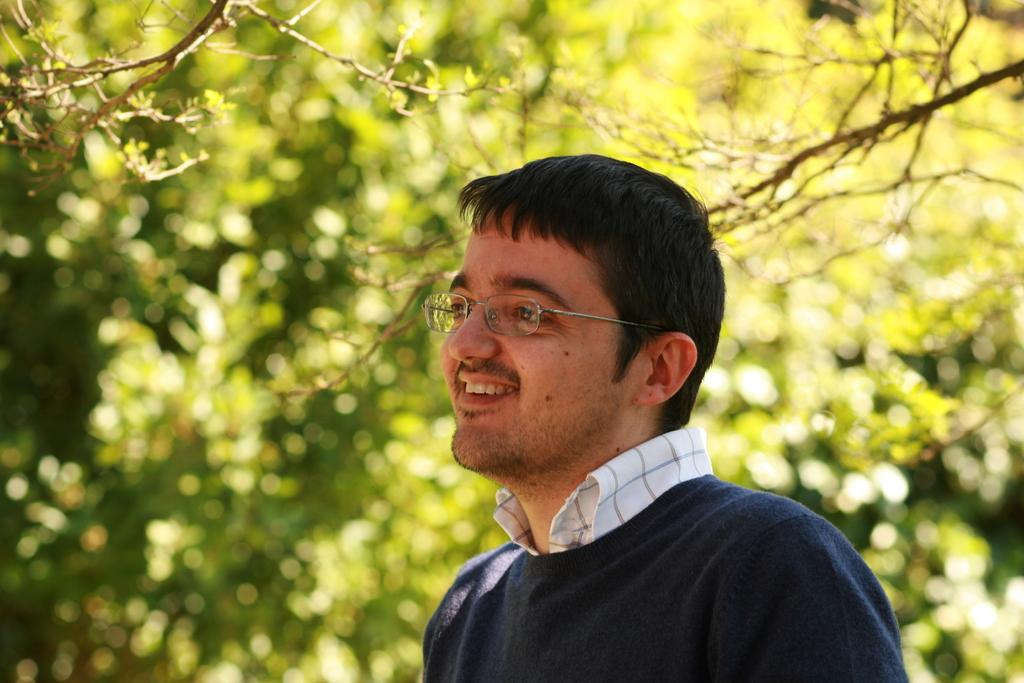Who is present in the image? There is a man in the image. What is the man doing in the image? The man is smiling in the image. What accessory is the man wearing? The man is wearing spectacles in the image. What can be seen in the background of the image? There are trees in the background of the image. What type of sand can be seen in the image? There is no sand present in the image. What sound does the alarm make in the image? There is no alarm present in the image. 